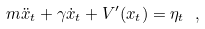<formula> <loc_0><loc_0><loc_500><loc_500>m \ddot { x } _ { t } + \gamma \dot { x } _ { t } + V ^ { \prime } ( x _ { t } ) = \eta _ { t } \ ,</formula> 